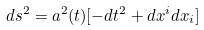Convert formula to latex. <formula><loc_0><loc_0><loc_500><loc_500>d s ^ { 2 } = a ^ { 2 } ( t ) [ - d t ^ { 2 } + d x ^ { i } d x _ { i } ]</formula> 